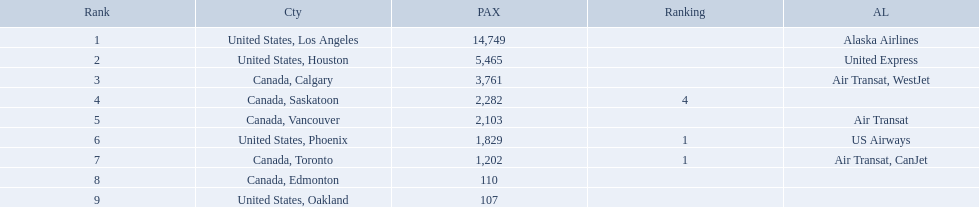Write the full table. {'header': ['Rank', 'Cty', 'PAX', 'Ranking', 'AL'], 'rows': [['1', 'United States, Los Angeles', '14,749', '', 'Alaska Airlines'], ['2', 'United States, Houston', '5,465', '', 'United Express'], ['3', 'Canada, Calgary', '3,761', '', 'Air Transat, WestJet'], ['4', 'Canada, Saskatoon', '2,282', '4', ''], ['5', 'Canada, Vancouver', '2,103', '', 'Air Transat'], ['6', 'United States, Phoenix', '1,829', '1', 'US Airways'], ['7', 'Canada, Toronto', '1,202', '1', 'Air Transat, CanJet'], ['8', 'Canada, Edmonton', '110', '', ''], ['9', 'United States, Oakland', '107', '', '']]} What were all the passenger totals? 14,749, 5,465, 3,761, 2,282, 2,103, 1,829, 1,202, 110, 107. Which of these were to los angeles? 14,749. What other destination combined with this is closest to 19,000? Canada, Calgary. What are the cities that are associated with the playa de oro international airport? United States, Los Angeles, United States, Houston, Canada, Calgary, Canada, Saskatoon, Canada, Vancouver, United States, Phoenix, Canada, Toronto, Canada, Edmonton, United States, Oakland. What is uniteed states, los angeles passenger count? 14,749. What other cities passenger count would lead to 19,000 roughly when combined with previous los angeles? Canada, Calgary. Where are the destinations of the airport? United States, Los Angeles, United States, Houston, Canada, Calgary, Canada, Saskatoon, Canada, Vancouver, United States, Phoenix, Canada, Toronto, Canada, Edmonton, United States, Oakland. What is the number of passengers to phoenix? 1,829. 